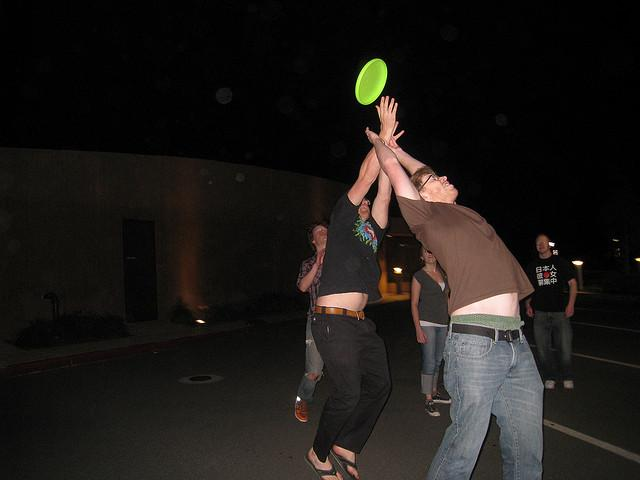WHat language is on the black shirt? chinese 